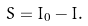Convert formula to latex. <formula><loc_0><loc_0><loc_500><loc_500>S = I _ { 0 } - I .</formula> 